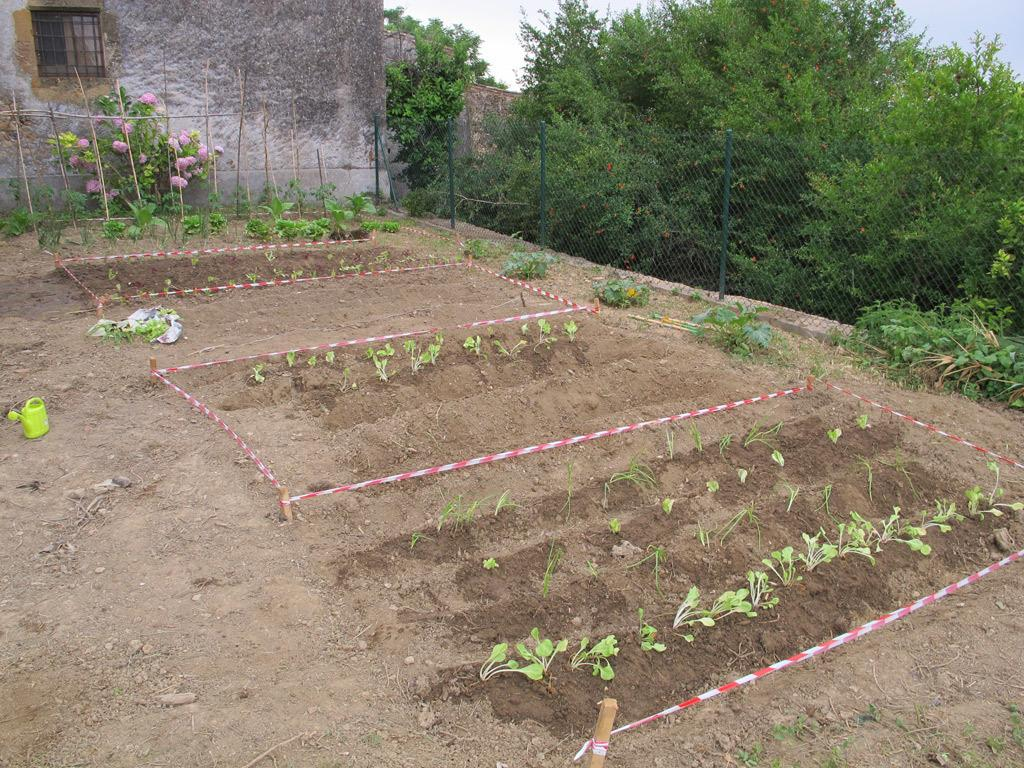What type of outdoor space is depicted in the image? There is a garden in the image. What can be found within the garden? There are plants, flowers, trees, a mesh, and holes in the garden. Are there any structures visible in the garden? Yes, there are houses, walls, and a window visible in the garden. Where is the water can located in the image? The water can is present on the left side of the image. What type of business is being conducted in the garden? There is no indication of any business being conducted in the garden; it is a residential or recreational space. Can you see a twig in the garden? The provided facts do not mention a twig, so it cannot be confirmed whether a twig is present in the garden or not. 